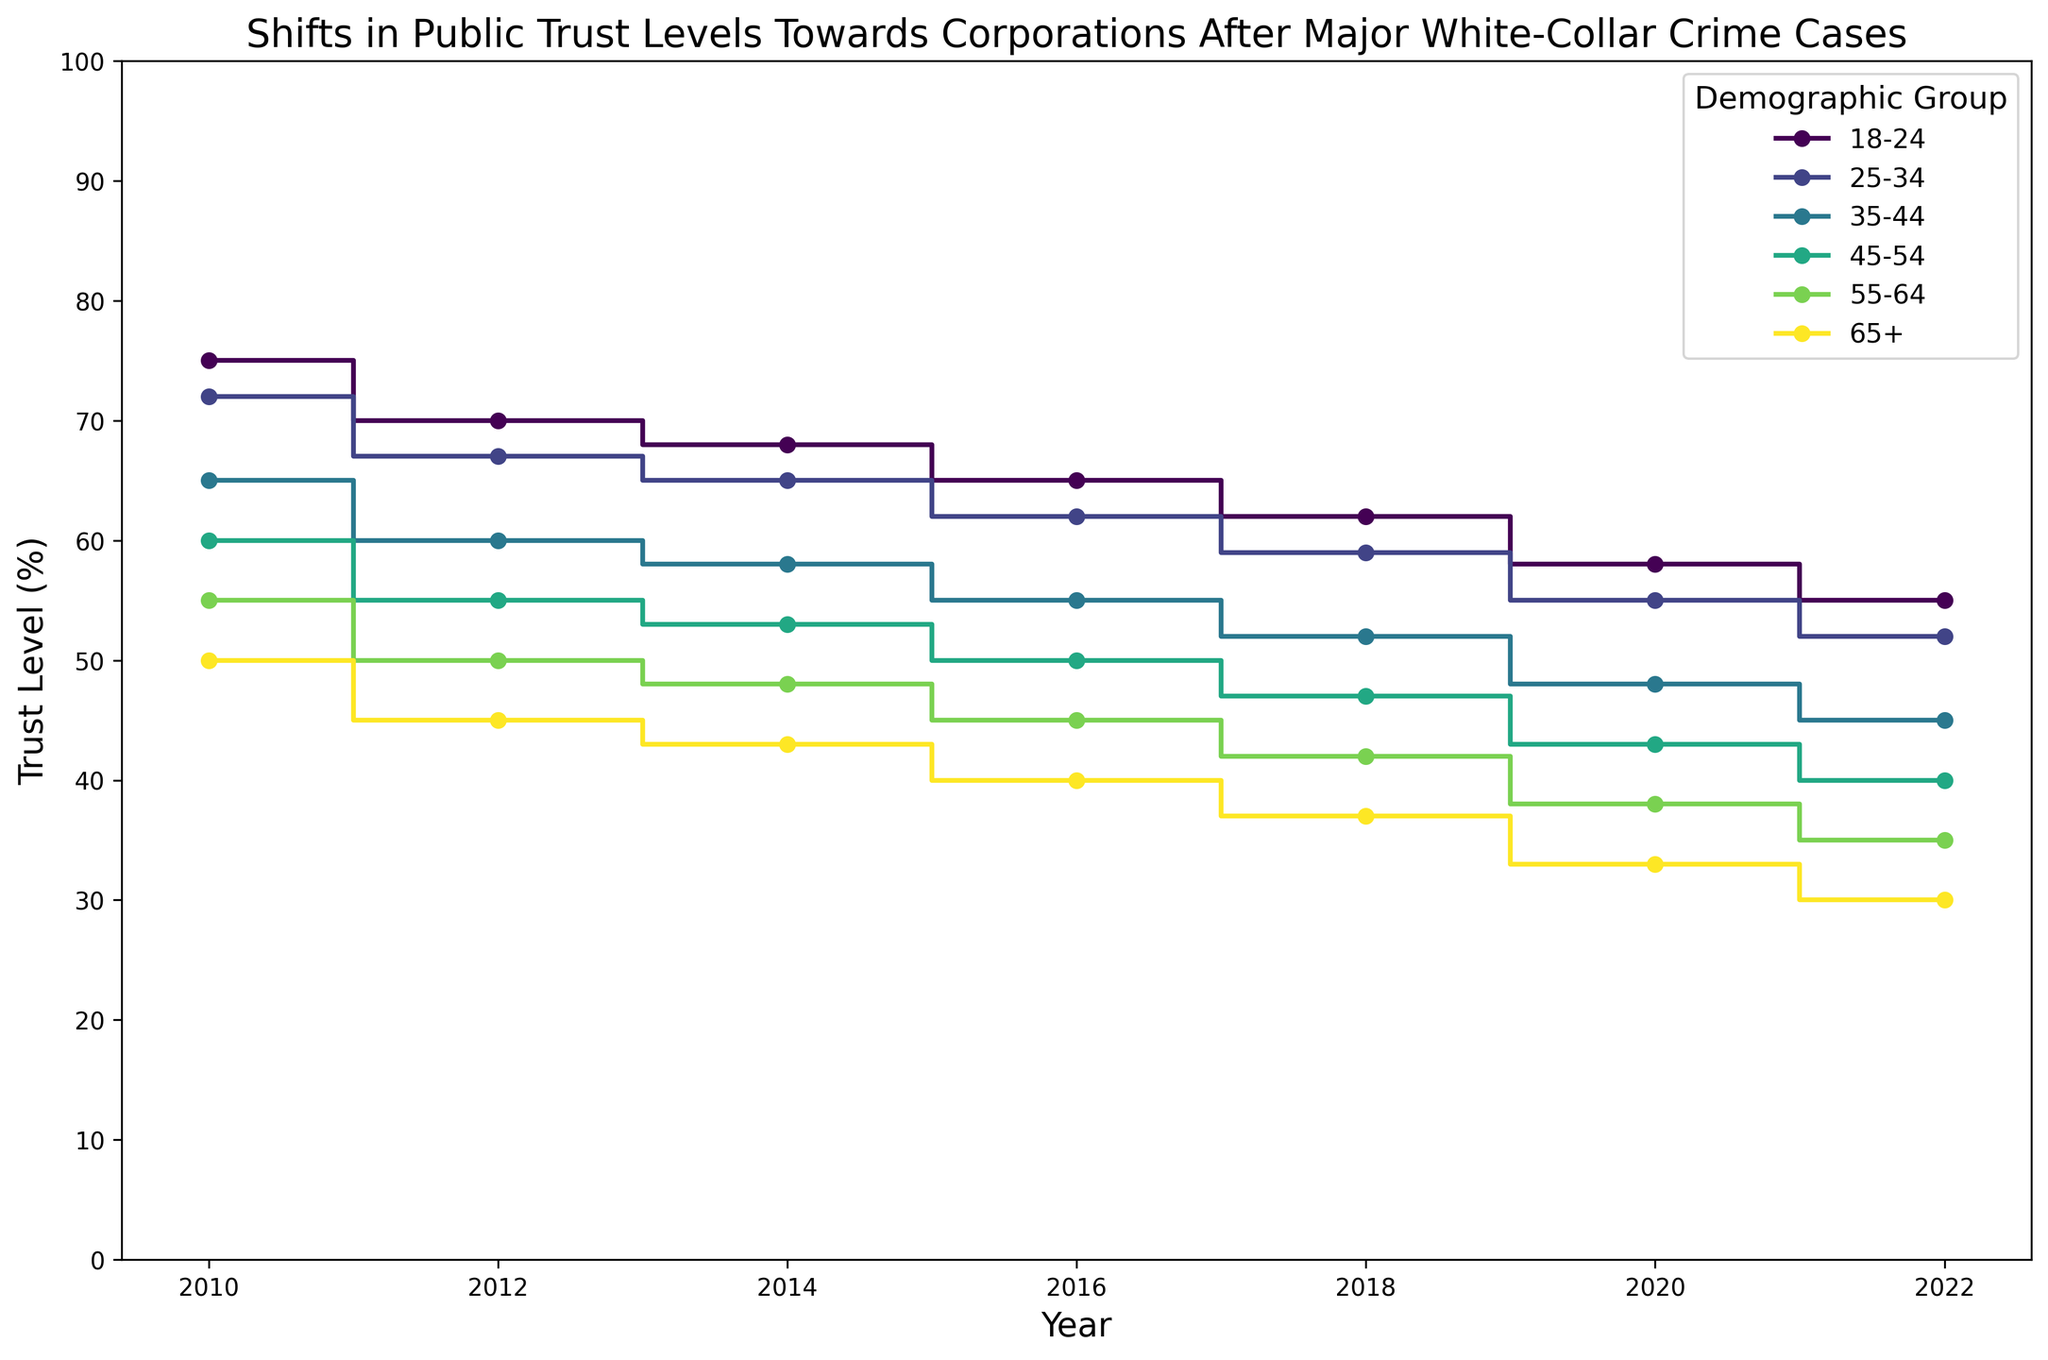What is the trend of trust levels for the demographic group '18-24' from 2010 to 2022? Observing the plot, the trust levels for the '18-24’ group show a decreasing trend, beginning at 75% in 2010 and declining to 55% in 2022. Each step in the stairs plot shows a drop at regular intervals (2012, 2014, 2016, 2018, 2020, 2022).
Answer: Decreasing Which demographic group had the highest trust level in 2022? The '18-24' demographic group had the highest trust level in 2022. The final value for each demographic is marked with a point, and the '18-24' group's point is the highest at 55%.
Answer: 18-24 Which two demographic groups had the largest difference in trust levels in 2012? Comparing the levels for each group from the plot at the 2012 mark, '18-24' has a trust level of 70% and '65+' has 45%. The difference between their levels is 25%, which is the largest among the groups.
Answer: 18-24 and 65+ How does the trust level of the '25-34' demographic change between 2010 and 2022? From the start value at 72% in 2010, the '25-34' group’s trust level steadily decreases to 52% in 2022. The plot shows a clear downward trend with steps marking each interval’s decrease.
Answer: Decreases Which demographic showed the most significant percentage decrease in trust level from 2010 to 2022? Calculating the percentage decrease for each demographic from 2010 to 2022, '65+' has the highest decline from 50% to 30%, a 40% reduction. This is the most significant among all groups.
Answer: 65+ What is the median trust level for the '35-44' demographic from 2010 to 2022? The trust levels for '35-44' from 2010 to 2022 are 65%, 60%, 58%, 55%, 52%, 48%, and 45%. Ordering these, the middle value (median) is 55%.
Answer: 55% Between which two intervals did the '55-64' demographic experience the steepest drop in trust levels? Observing the plot and the numerical change, the steepest drop for the '55-64' group occurs between 2010 (55%) and 2012 (50%), a 5% decrease. This is the most significant drop compared to other intervals.
Answer: 2010-2012 Which demographic consistently had the lowest trust levels throughout all the years? From the plot, it is clear that across all years (2010 to 2022), the '65+' group consistently shows the lowest trust levels, ending at 30% in 2022.
Answer: 65+ What is the average trust level of the '45-54' demographic over the period? Compiling the trust levels from each year for '45-54' (60%, 55%, 53%, 50%, 47%, 43%, 40%), summing these yields 348%. With seven values, the average trust level is 348% / 7 ≈ 49.7%.
Answer: 49.7% 